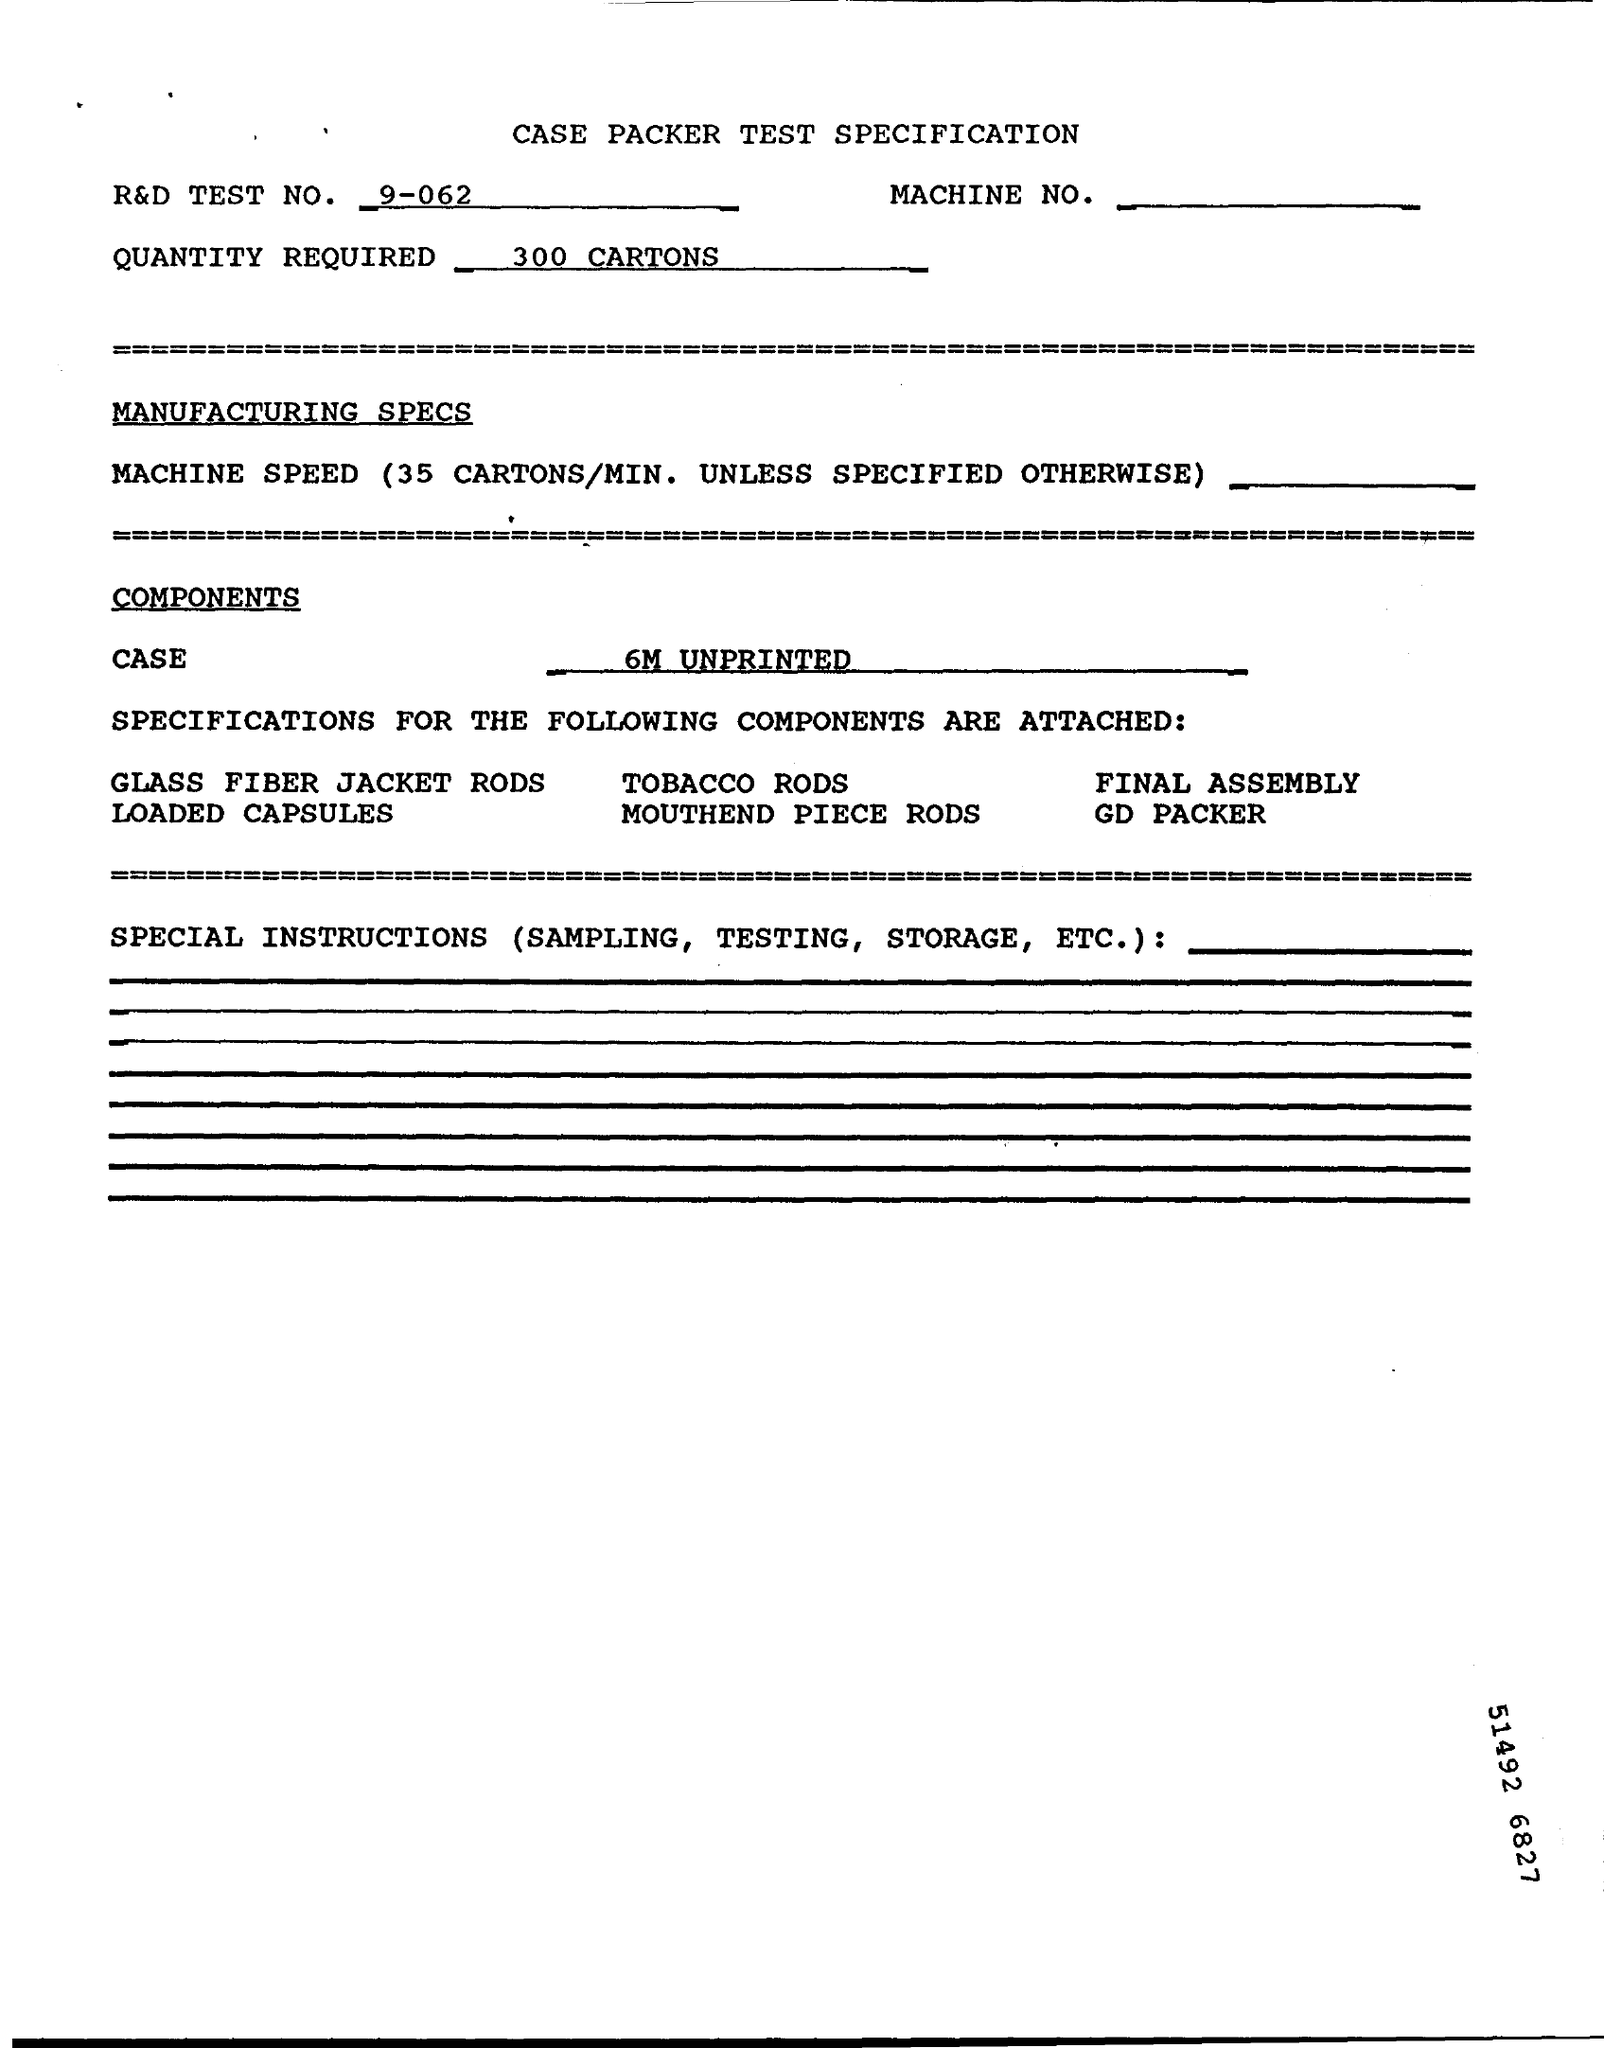What is the R&D Test No.?
Give a very brief answer. 9-062. What is the Quantity Required?
Give a very brief answer. 300 Cartons. What is the Case?
Your answer should be compact. 6M UNPRINTED. 